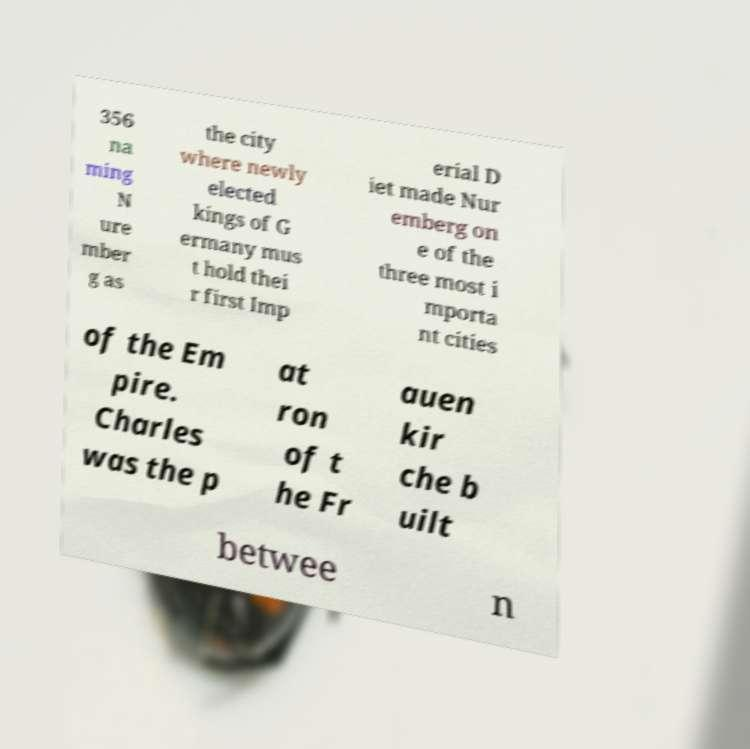Could you assist in decoding the text presented in this image and type it out clearly? 356 na ming N ure mber g as the city where newly elected kings of G ermany mus t hold thei r first Imp erial D iet made Nur emberg on e of the three most i mporta nt cities of the Em pire. Charles was the p at ron of t he Fr auen kir che b uilt betwee n 